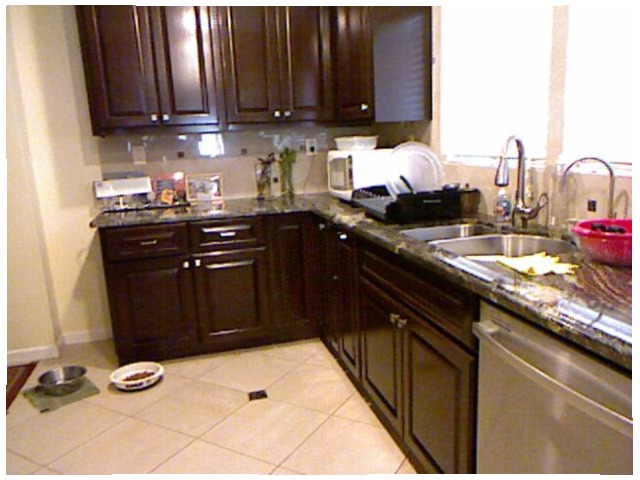<image>
Is the dog bowl under the tile? No. The dog bowl is not positioned under the tile. The vertical relationship between these objects is different. Is there a counter on the bowl? No. The counter is not positioned on the bowl. They may be near each other, but the counter is not supported by or resting on top of the bowl. Where is the wall in relation to the cupboard? Is it behind the cupboard? Yes. From this viewpoint, the wall is positioned behind the cupboard, with the cupboard partially or fully occluding the wall. Is the bowl above the floor? No. The bowl is not positioned above the floor. The vertical arrangement shows a different relationship. 